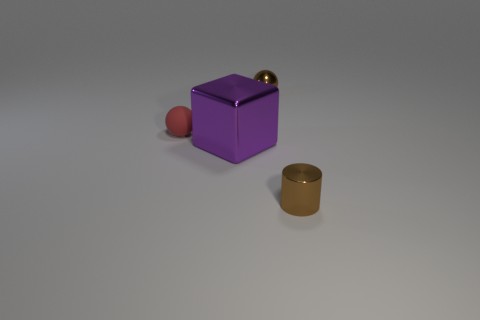Add 1 brown metallic cylinders. How many objects exist? 5 Subtract all cubes. How many objects are left? 3 Subtract 0 purple balls. How many objects are left? 4 Subtract all small red balls. Subtract all large purple metallic things. How many objects are left? 2 Add 4 red objects. How many red objects are left? 5 Add 2 large metallic things. How many large metallic things exist? 3 